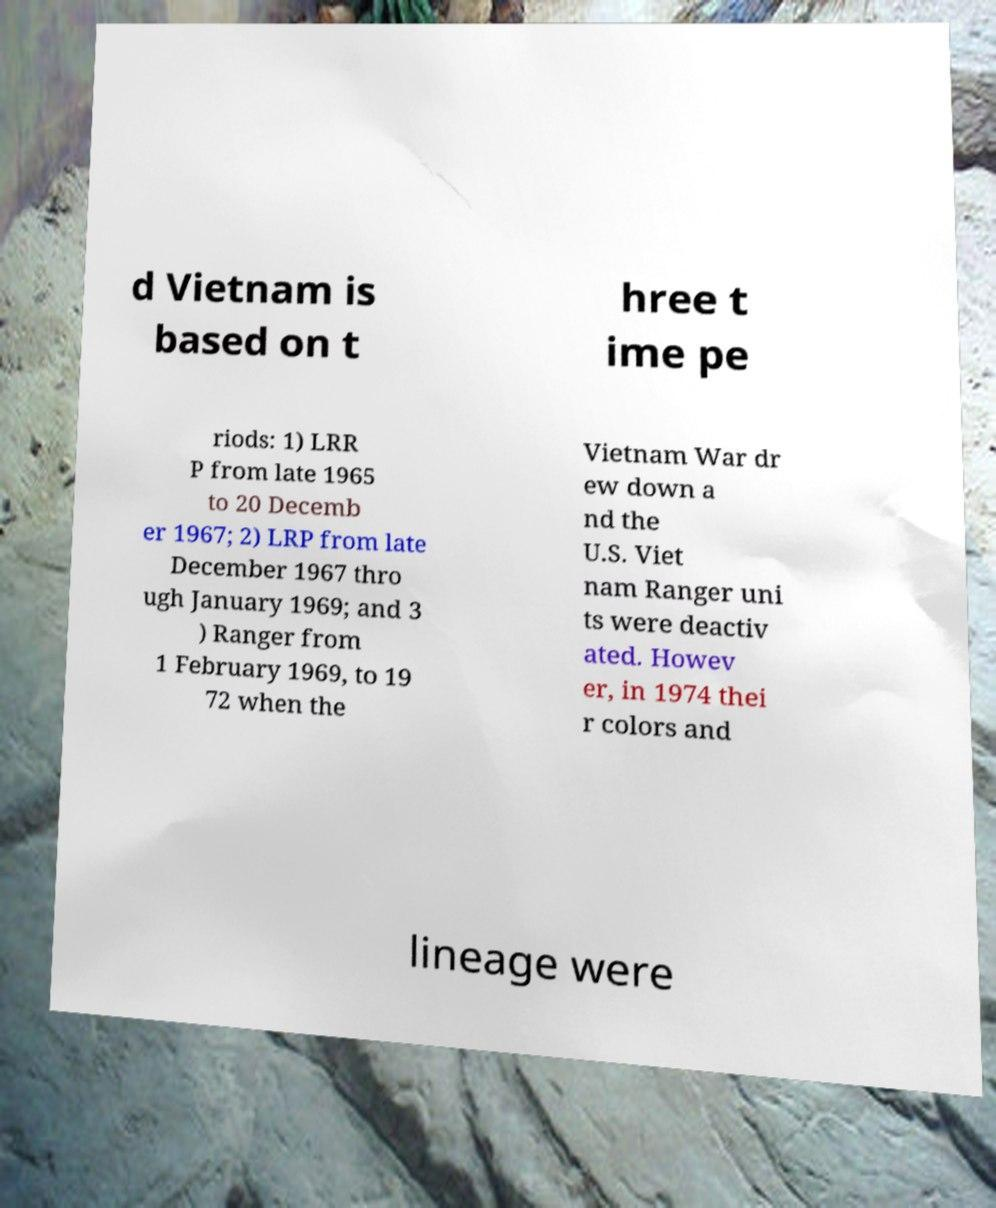Can you read and provide the text displayed in the image?This photo seems to have some interesting text. Can you extract and type it out for me? d Vietnam is based on t hree t ime pe riods: 1) LRR P from late 1965 to 20 Decemb er 1967; 2) LRP from late December 1967 thro ugh January 1969; and 3 ) Ranger from 1 February 1969, to 19 72 when the Vietnam War dr ew down a nd the U.S. Viet nam Ranger uni ts were deactiv ated. Howev er, in 1974 thei r colors and lineage were 